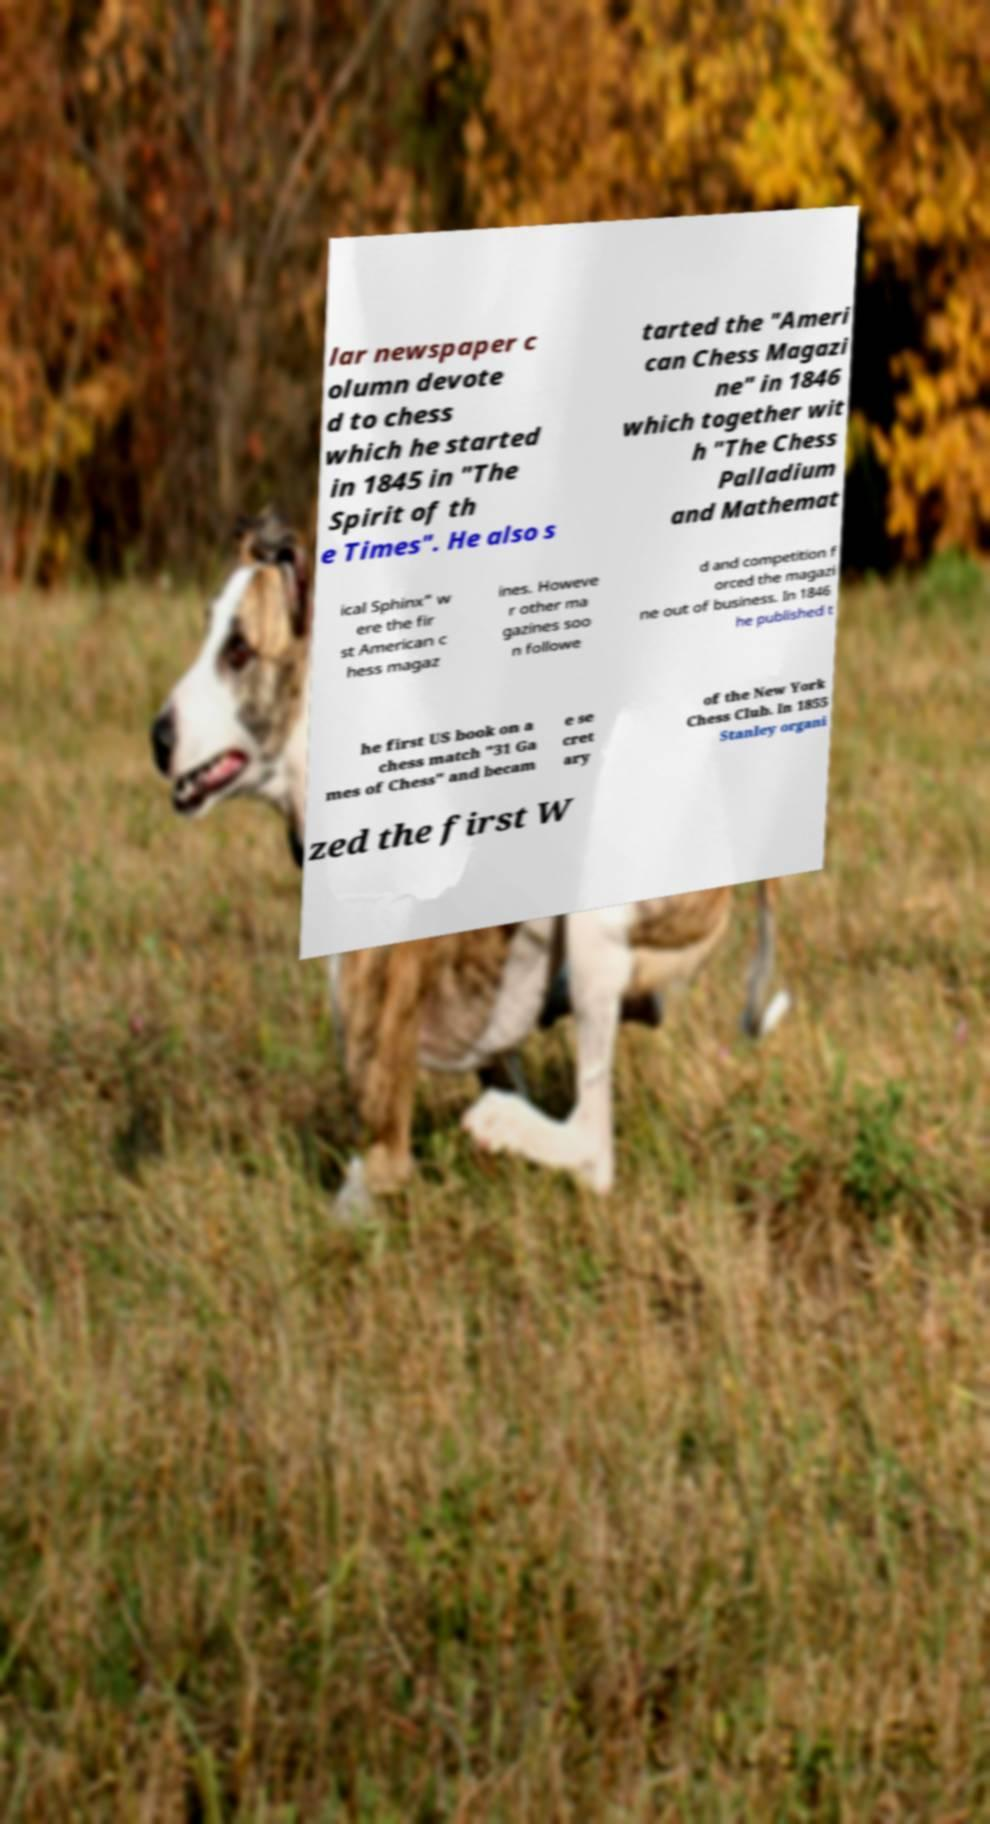Can you accurately transcribe the text from the provided image for me? lar newspaper c olumn devote d to chess which he started in 1845 in "The Spirit of th e Times". He also s tarted the "Ameri can Chess Magazi ne" in 1846 which together wit h "The Chess Palladium and Mathemat ical Sphinx" w ere the fir st American c hess magaz ines. Howeve r other ma gazines soo n followe d and competition f orced the magazi ne out of business. In 1846 he published t he first US book on a chess match "31 Ga mes of Chess" and becam e se cret ary of the New York Chess Club. In 1855 Stanley organi zed the first W 